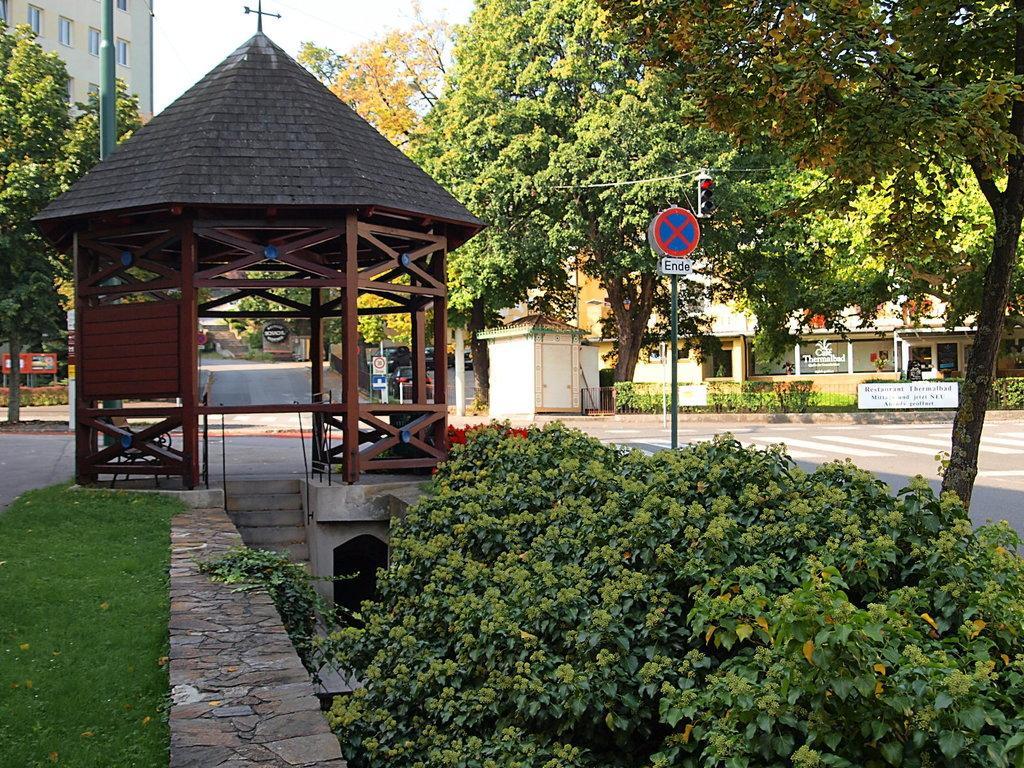Describe this image in one or two sentences. In the center of the image there is a wooden structure with roof. At the bottom of the image there are plants. There is grass. In the background of the image there is a building. There are trees. There is a pole. To the right side of the image there is a road. There is a sign board. 